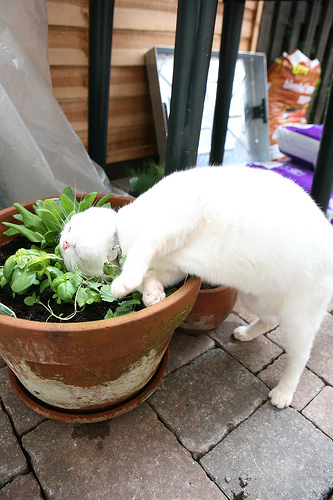Do the cat and the plant have the sharegpt4v/same color? No, the cat and the plant do not have the sharegpt4v/same color. 